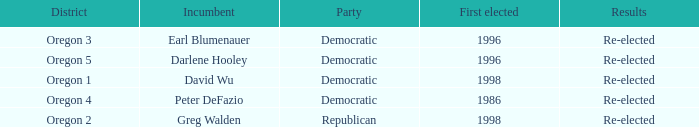Which Democratic incumbent was first elected in 1998? David Wu. 